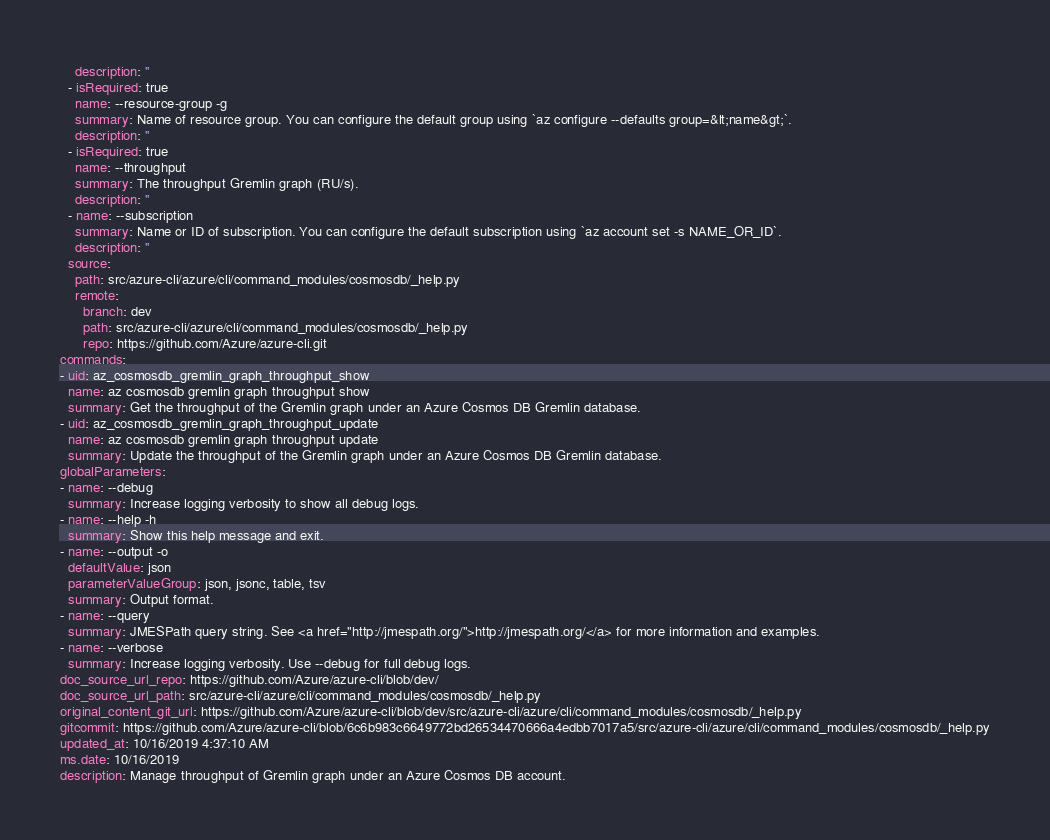<code> <loc_0><loc_0><loc_500><loc_500><_YAML_>    description: ''
  - isRequired: true
    name: --resource-group -g
    summary: Name of resource group. You can configure the default group using `az configure --defaults group=&lt;name&gt;`.
    description: ''
  - isRequired: true
    name: --throughput
    summary: The throughput Gremlin graph (RU/s).
    description: ''
  - name: --subscription
    summary: Name or ID of subscription. You can configure the default subscription using `az account set -s NAME_OR_ID`.
    description: ''
  source:
    path: src/azure-cli/azure/cli/command_modules/cosmosdb/_help.py
    remote:
      branch: dev
      path: src/azure-cli/azure/cli/command_modules/cosmosdb/_help.py
      repo: https://github.com/Azure/azure-cli.git
commands:
- uid: az_cosmosdb_gremlin_graph_throughput_show
  name: az cosmosdb gremlin graph throughput show
  summary: Get the throughput of the Gremlin graph under an Azure Cosmos DB Gremlin database.
- uid: az_cosmosdb_gremlin_graph_throughput_update
  name: az cosmosdb gremlin graph throughput update
  summary: Update the throughput of the Gremlin graph under an Azure Cosmos DB Gremlin database.
globalParameters:
- name: --debug
  summary: Increase logging verbosity to show all debug logs.
- name: --help -h
  summary: Show this help message and exit.
- name: --output -o
  defaultValue: json
  parameterValueGroup: json, jsonc, table, tsv
  summary: Output format.
- name: --query
  summary: JMESPath query string. See <a href="http://jmespath.org/">http://jmespath.org/</a> for more information and examples.
- name: --verbose
  summary: Increase logging verbosity. Use --debug for full debug logs.
doc_source_url_repo: https://github.com/Azure/azure-cli/blob/dev/
doc_source_url_path: src/azure-cli/azure/cli/command_modules/cosmosdb/_help.py
original_content_git_url: https://github.com/Azure/azure-cli/blob/dev/src/azure-cli/azure/cli/command_modules/cosmosdb/_help.py
gitcommit: https://github.com/Azure/azure-cli/blob/6c6b983c6649772bd26534470666a4edbb7017a5/src/azure-cli/azure/cli/command_modules/cosmosdb/_help.py
updated_at: 10/16/2019 4:37:10 AM
ms.date: 10/16/2019
description: Manage throughput of Gremlin graph under an Azure Cosmos DB account.
</code> 